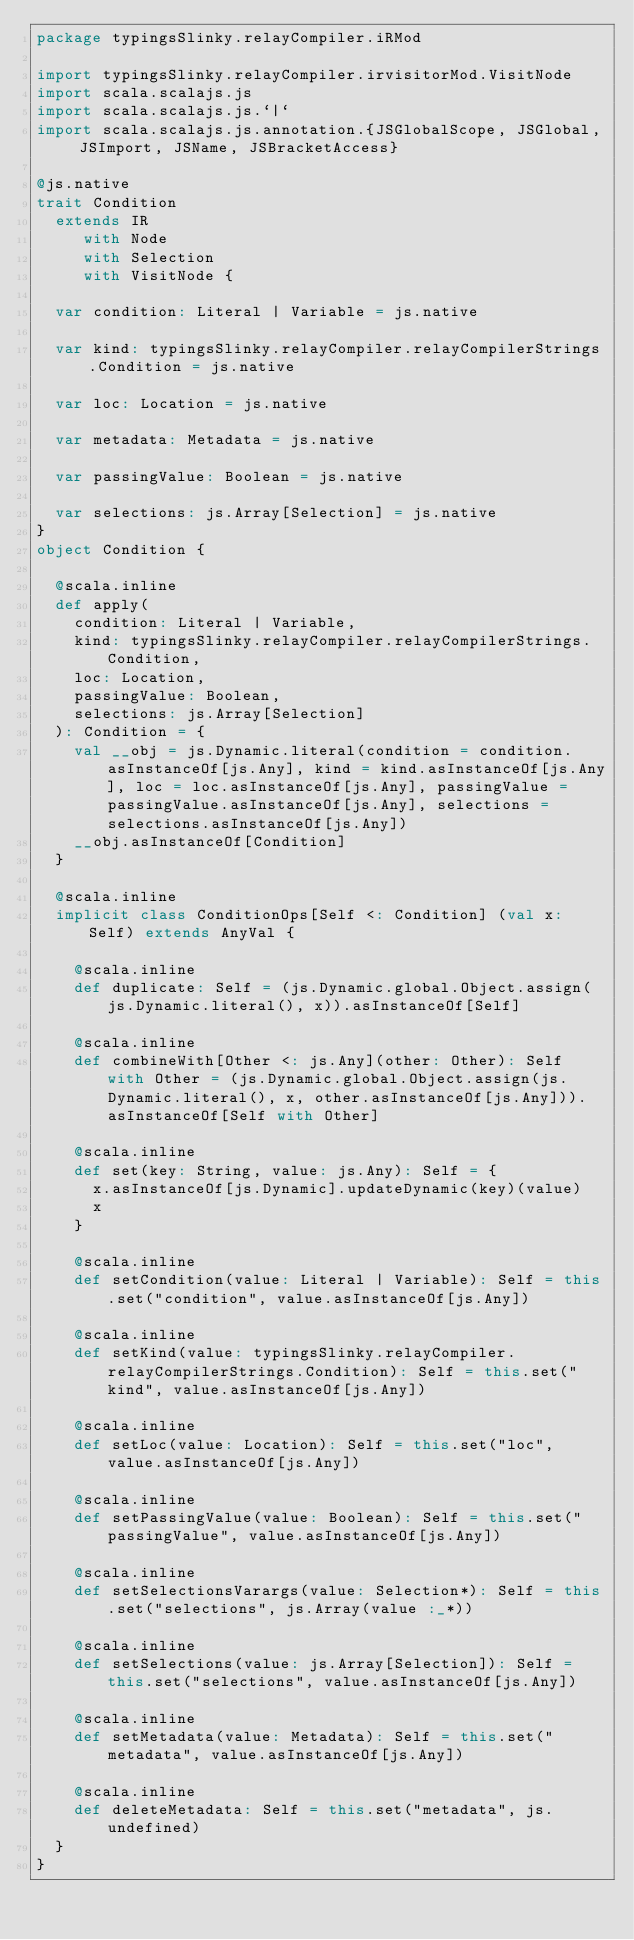<code> <loc_0><loc_0><loc_500><loc_500><_Scala_>package typingsSlinky.relayCompiler.iRMod

import typingsSlinky.relayCompiler.irvisitorMod.VisitNode
import scala.scalajs.js
import scala.scalajs.js.`|`
import scala.scalajs.js.annotation.{JSGlobalScope, JSGlobal, JSImport, JSName, JSBracketAccess}

@js.native
trait Condition
  extends IR
     with Node
     with Selection
     with VisitNode {
  
  var condition: Literal | Variable = js.native
  
  var kind: typingsSlinky.relayCompiler.relayCompilerStrings.Condition = js.native
  
  var loc: Location = js.native
  
  var metadata: Metadata = js.native
  
  var passingValue: Boolean = js.native
  
  var selections: js.Array[Selection] = js.native
}
object Condition {
  
  @scala.inline
  def apply(
    condition: Literal | Variable,
    kind: typingsSlinky.relayCompiler.relayCompilerStrings.Condition,
    loc: Location,
    passingValue: Boolean,
    selections: js.Array[Selection]
  ): Condition = {
    val __obj = js.Dynamic.literal(condition = condition.asInstanceOf[js.Any], kind = kind.asInstanceOf[js.Any], loc = loc.asInstanceOf[js.Any], passingValue = passingValue.asInstanceOf[js.Any], selections = selections.asInstanceOf[js.Any])
    __obj.asInstanceOf[Condition]
  }
  
  @scala.inline
  implicit class ConditionOps[Self <: Condition] (val x: Self) extends AnyVal {
    
    @scala.inline
    def duplicate: Self = (js.Dynamic.global.Object.assign(js.Dynamic.literal(), x)).asInstanceOf[Self]
    
    @scala.inline
    def combineWith[Other <: js.Any](other: Other): Self with Other = (js.Dynamic.global.Object.assign(js.Dynamic.literal(), x, other.asInstanceOf[js.Any])).asInstanceOf[Self with Other]
    
    @scala.inline
    def set(key: String, value: js.Any): Self = {
      x.asInstanceOf[js.Dynamic].updateDynamic(key)(value)
      x
    }
    
    @scala.inline
    def setCondition(value: Literal | Variable): Self = this.set("condition", value.asInstanceOf[js.Any])
    
    @scala.inline
    def setKind(value: typingsSlinky.relayCompiler.relayCompilerStrings.Condition): Self = this.set("kind", value.asInstanceOf[js.Any])
    
    @scala.inline
    def setLoc(value: Location): Self = this.set("loc", value.asInstanceOf[js.Any])
    
    @scala.inline
    def setPassingValue(value: Boolean): Self = this.set("passingValue", value.asInstanceOf[js.Any])
    
    @scala.inline
    def setSelectionsVarargs(value: Selection*): Self = this.set("selections", js.Array(value :_*))
    
    @scala.inline
    def setSelections(value: js.Array[Selection]): Self = this.set("selections", value.asInstanceOf[js.Any])
    
    @scala.inline
    def setMetadata(value: Metadata): Self = this.set("metadata", value.asInstanceOf[js.Any])
    
    @scala.inline
    def deleteMetadata: Self = this.set("metadata", js.undefined)
  }
}
</code> 